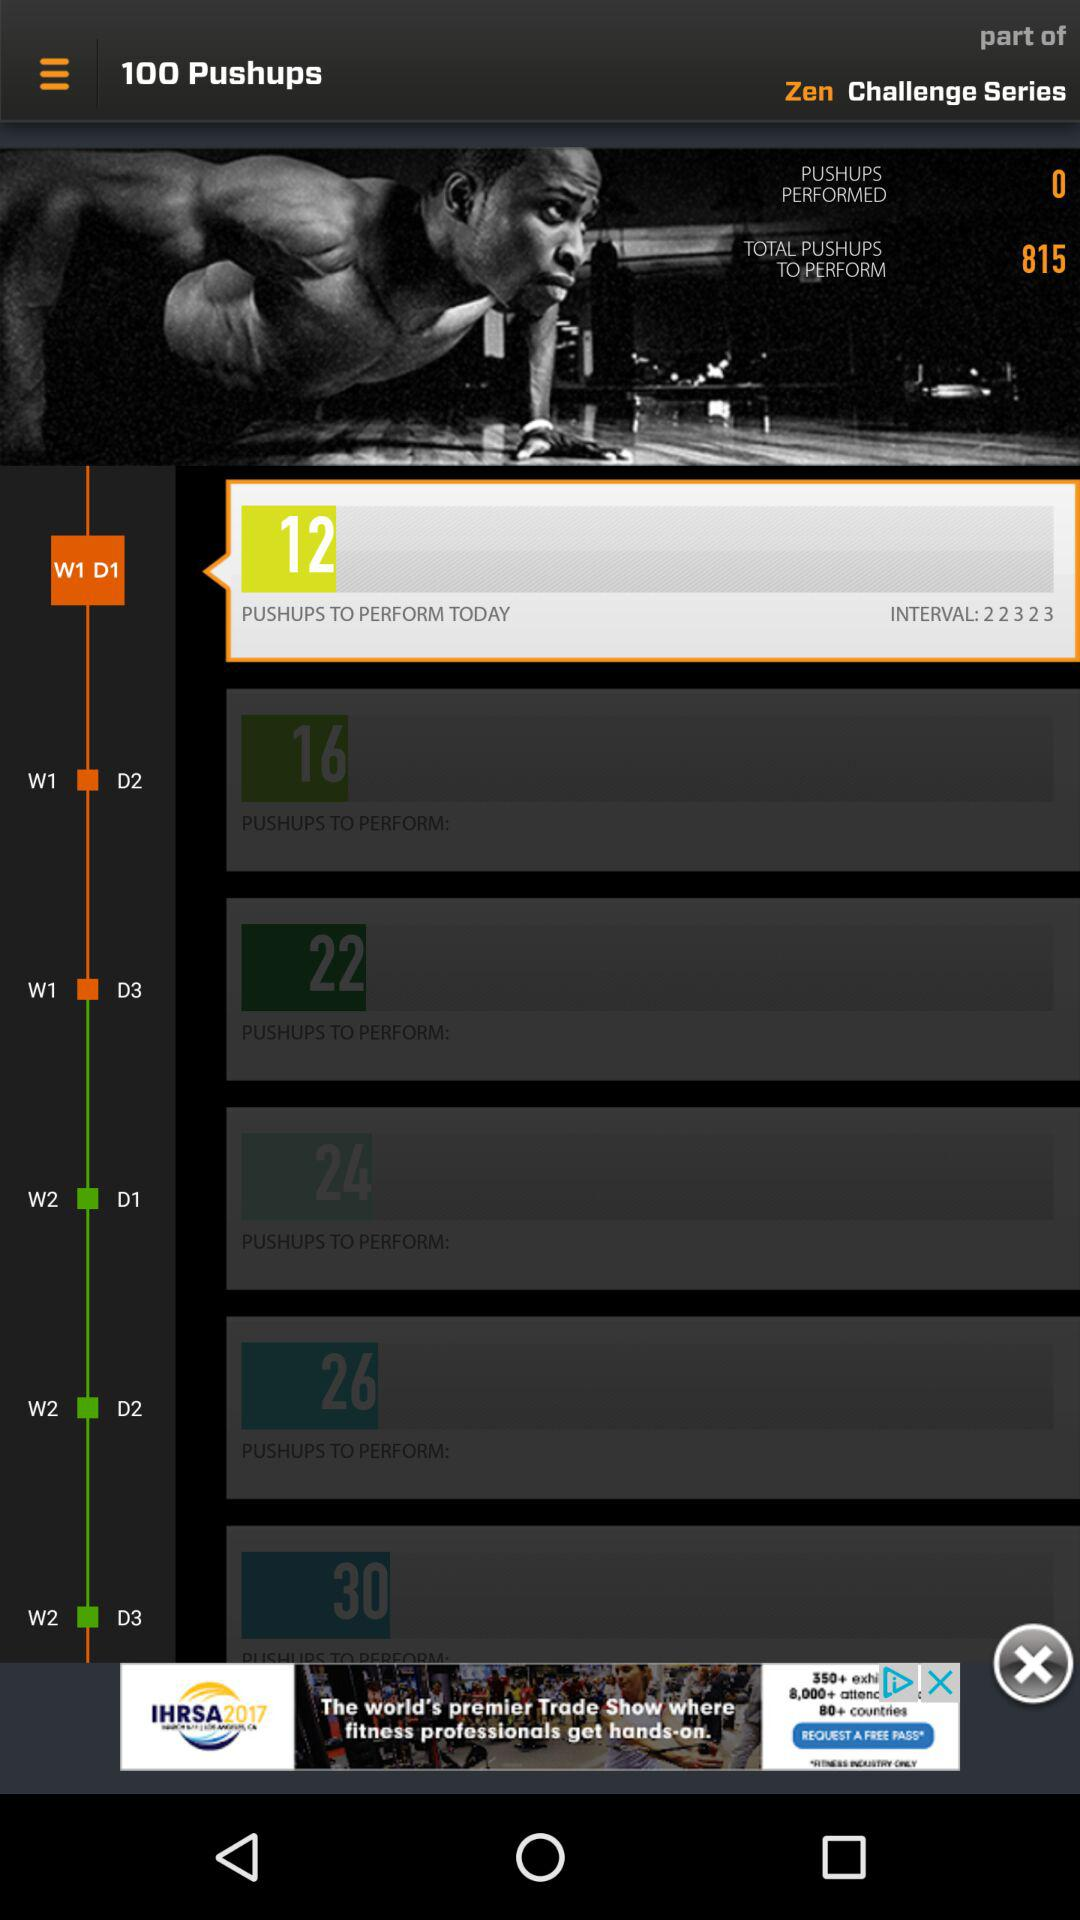What is the number of "TOTAL PUSHUPS TO PERFORM"? The number of "TOTAL PUSHUPS TO PERFORM" is 815. 